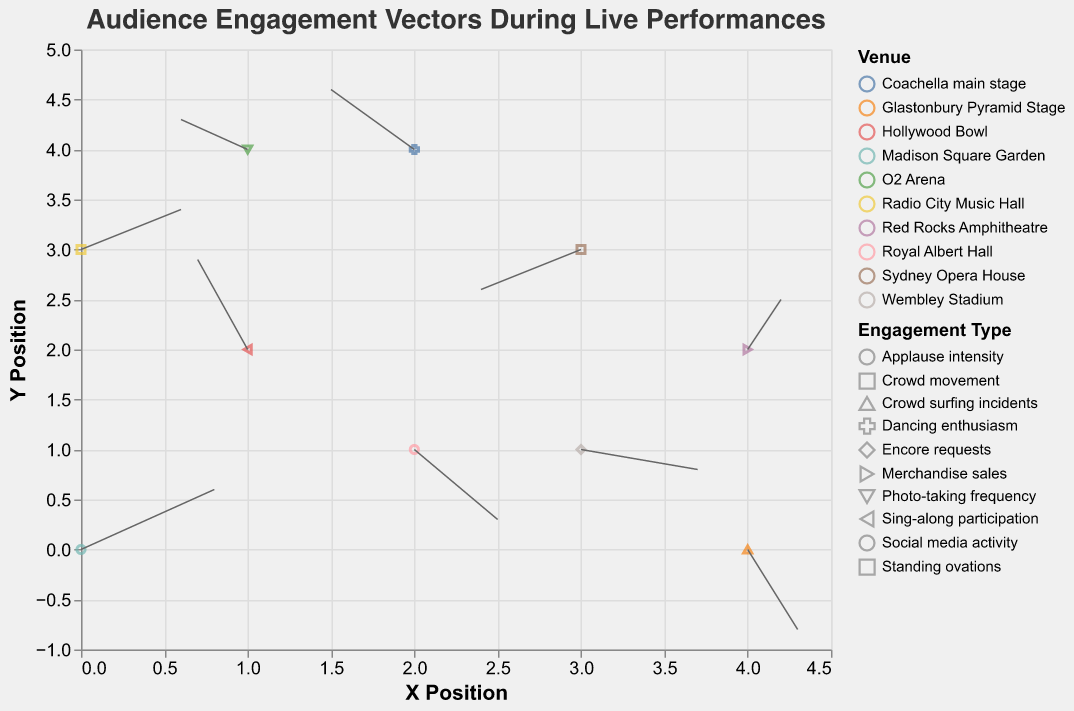What is the title of the figure? The title is usually displayed at the top of the figure, providing an overview of what the visual represents. This particular plot is titled "Audience Engagement Vectors During Live Performances" which suggests it visualizes some form of audience engagement at live venues.
Answer: Audience Engagement Vectors During Live Performances Which venue shows the highest applause intensity? To find the venue with the highest applause intensity, look for the vector starting at the origin (0,0), which represents "Madison Square Garden" with vector (0.8, 0.6). The direction and length of the vector indicate the intensity.
Answer: Madison Square Garden Which venue is associated with social media activity? The dataset labels each vector with an engagement type and venue. By locating the row where the engagement type is "Social media activity," it corresponds to the vector starting at (2,1) and moving in (0.5, -0.7) direction from "Royal Albert Hall."
Answer: Royal Albert Hall At which venue do audience members show the highest sing-along participation? Check for the vector indicating "Sing-along participation," which starts at (1,2) and moves in (-0.3, 0.9) direction. This is associated with the "Hollywood Bowl."
Answer: Hollywood Bowl Which venue has a negative engagement vector in both x and y directions? We look for a vector where both u and v are negative. The venue "Sydney Opera House" at (3,3) with vector (-0.6, -0.4) fits this description.
Answer: Sydney Opera House How does engagement at "O2 Arena" differ in x and y direction? The engagement vector at "O2 Arena" starts at (1,4) and moves with values of u = -0.4 and v = 0.3. This indicates a slight decrease in the x direction and slight increase in the y direction.
Answer: Decrease in x, Increase in y What is the general crowd movement direction at "Glastonbury Pyramid Stage"? The vector for "Glastonbury Pyramid Stage" starts at (4,0) and moves (0.3, -0.8), indicating crowd movement slightly to the right and largely downward.
Answer: Right and Downward Which venue has the highest vector magnitude for merchandise sales? Vector magnitude is calculated as the square root of (u^2 + v^2). For "Red Rocks Amphitheatre" (4,2) with vector (0.2,0.5), the magnitude is sqrt(0.2^2 + 0.5^2) = sqrt(0.29) = 0.54. Checking other venues, we find no other magnitude exceeds this for "Merchandise sales."
Answer: Red Rocks Amphitheatre What is the direction of the engagement vector for "Wembley Stadium"? The engagement vector for "Wembley Stadium" starts at (3,1) and moves in (0.7, -0.2). This points to the right and slightly downward.
Answer: Right and Downward Is dancing enthusiasm at "Coachella main stage" primarily positive along the y-axis? The vector for "Dancing enthusiasm" at "Coachella main stage" starts at (2,4) and moves (-0.5, 0.6). The positive y component (0.6) indicates a primarily positive direction along the y-axis.
Answer: Yes 